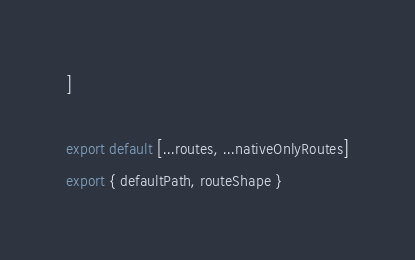<code> <loc_0><loc_0><loc_500><loc_500><_JavaScript_>]

export default [...routes, ...nativeOnlyRoutes]
export { defaultPath, routeShape }
</code> 